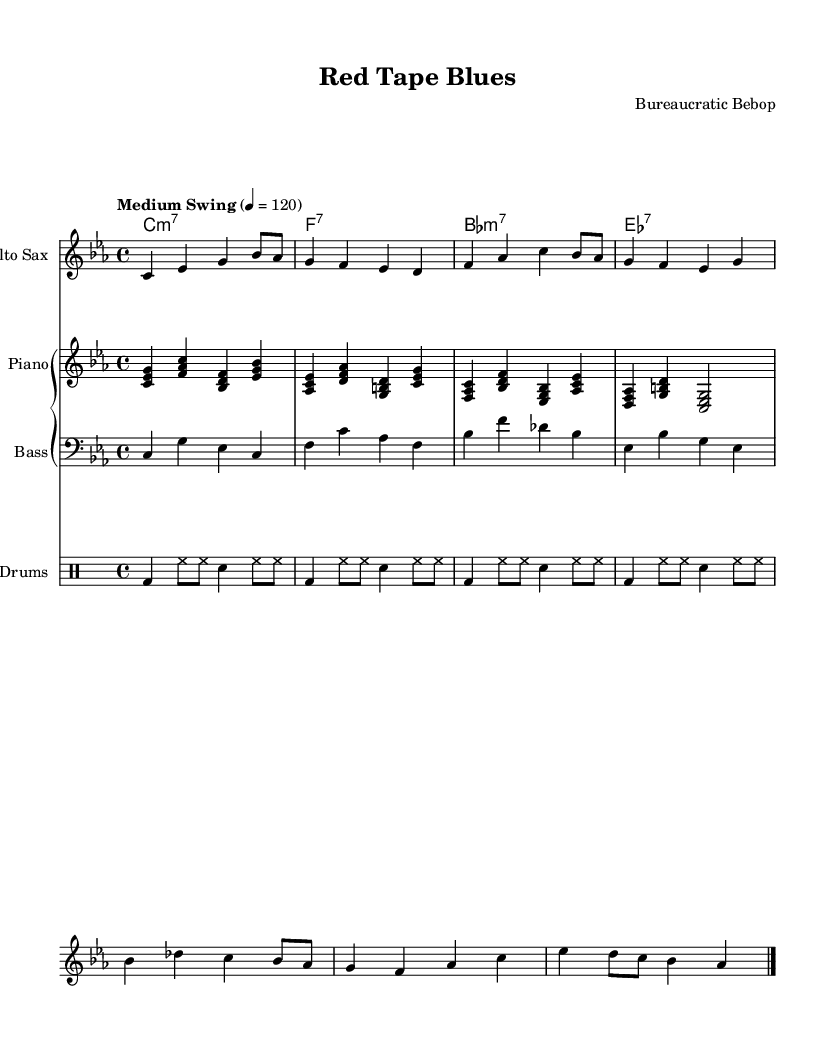What is the key signature of this music? The key signature is C minor, indicated by three flats in the signature at the beginning of the staff.
Answer: C minor What is the time signature of this piece? The time signature is 4/4, which is indicated by the notation at the beginning of the staff. This means there are four beats in each measure.
Answer: 4/4 What is the tempo of this composition? The tempo marking states "Medium Swing" with a metronome marking of 120 beats per minute, which indicates a moderate swing feel.
Answer: Medium Swing, 120 How many instruments are involved in this piece? The sheet music features four distinct parts: Alto Sax, Piano, Bass, and Drums, indicating a standard jazz ensemble setup.
Answer: Four instruments What type of chords are indicated in the chord names? The chord names include minor seventh chords (e.g., C minor 7) and dominant seventh chords (e.g., F7), typical of jazz compositions that require harmonic complexity.
Answer: Minor and dominant chords What is the structure of the melody for the Alto Sax? The melody consists of phrases with a mix of quarter notes and eighth notes, forming a repetitive yet syncopated rhythm, characteristic of cool jazz styling.
Answer: Syncopated rhythm How is the bass part characterized in this music? The bass part uses sustained notes in the lower register with a combination of quarter notes to maintain a steady pulse, contributing to the overall groove.
Answer: Sustained lower notes 